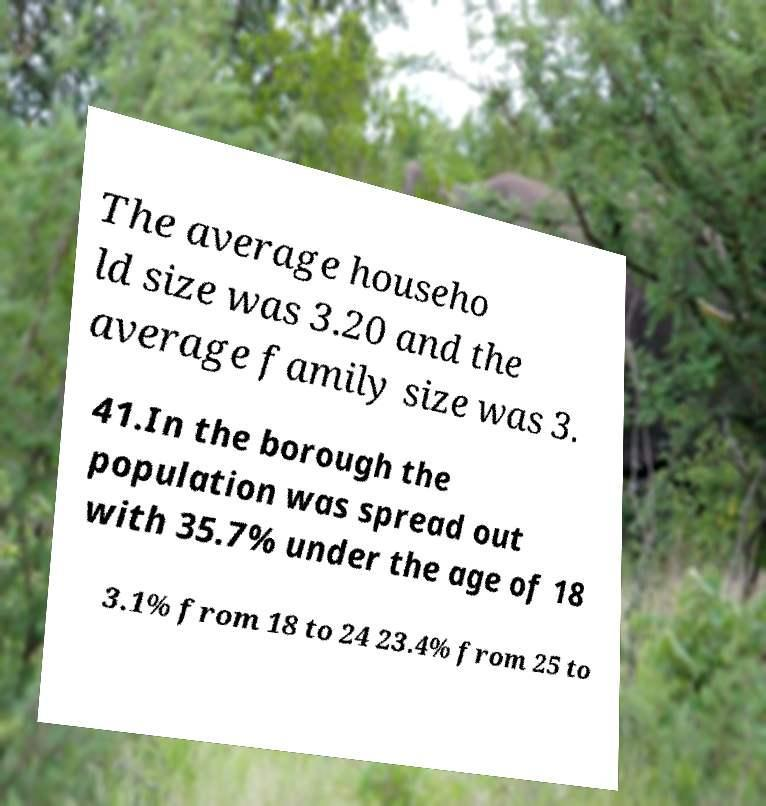Please identify and transcribe the text found in this image. The average househo ld size was 3.20 and the average family size was 3. 41.In the borough the population was spread out with 35.7% under the age of 18 3.1% from 18 to 24 23.4% from 25 to 